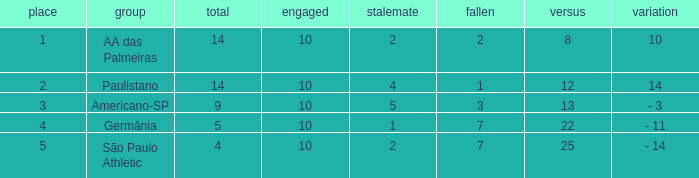What is the Against when the drawn is 5? 13.0. 